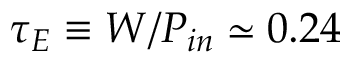<formula> <loc_0><loc_0><loc_500><loc_500>\tau _ { E } \equiv W / P _ { i n } \simeq 0 . 2 4</formula> 